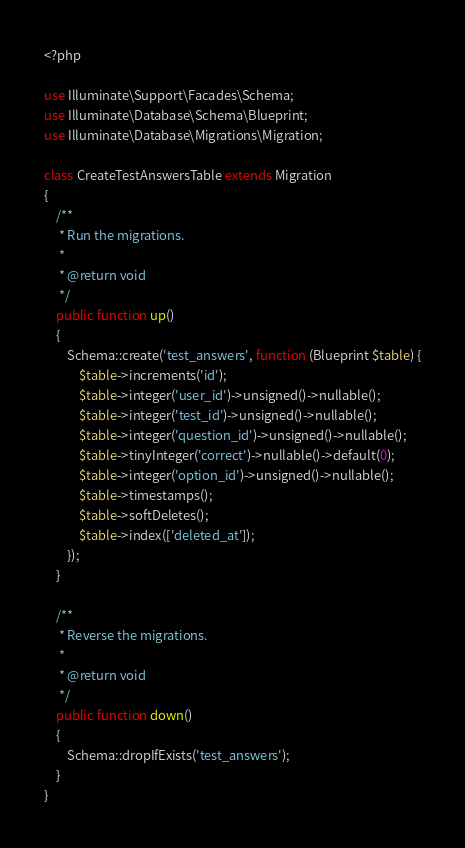<code> <loc_0><loc_0><loc_500><loc_500><_PHP_><?php

use Illuminate\Support\Facades\Schema;
use Illuminate\Database\Schema\Blueprint;
use Illuminate\Database\Migrations\Migration;

class CreateTestAnswersTable extends Migration
{
    /**
     * Run the migrations.
     *
     * @return void
     */
    public function up()
    {
        Schema::create('test_answers', function (Blueprint $table) {
            $table->increments('id');
            $table->integer('user_id')->unsigned()->nullable();
            $table->integer('test_id')->unsigned()->nullable();
            $table->integer('question_id')->unsigned()->nullable();
            $table->tinyInteger('correct')->nullable()->default(0);
            $table->integer('option_id')->unsigned()->nullable();
            $table->timestamps();
            $table->softDeletes();
            $table->index(['deleted_at']);
        });
    }

    /**
     * Reverse the migrations.
     *
     * @return void
     */
    public function down()
    {
        Schema::dropIfExists('test_answers');
    }
}
</code> 